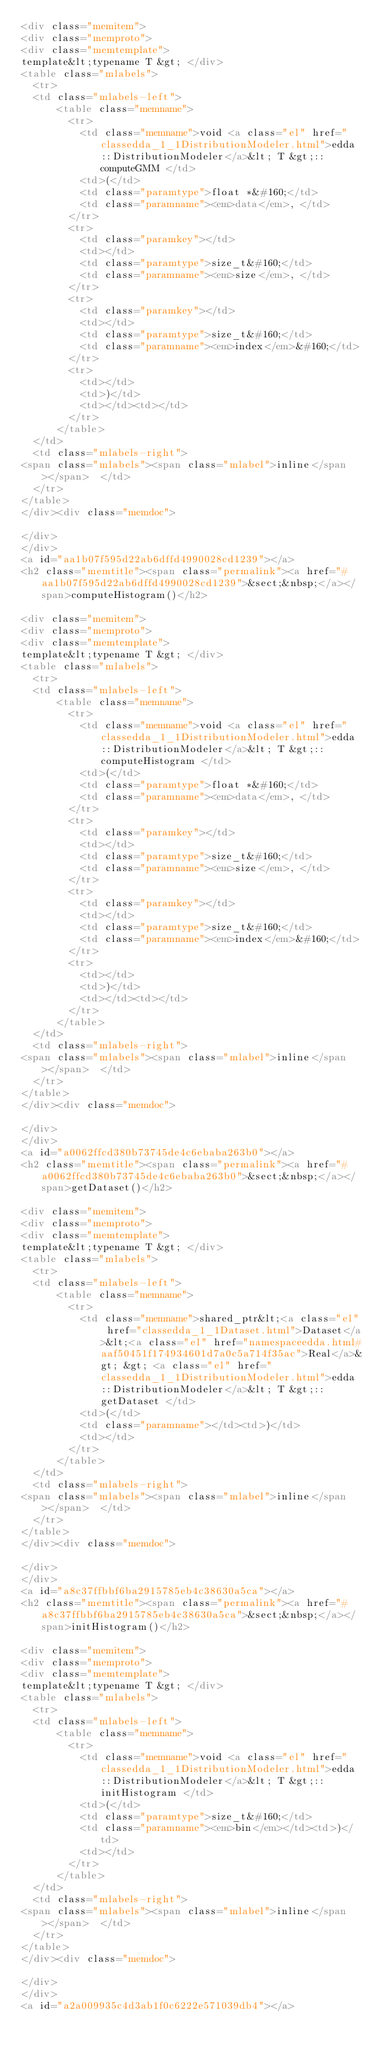<code> <loc_0><loc_0><loc_500><loc_500><_HTML_><div class="memitem">
<div class="memproto">
<div class="memtemplate">
template&lt;typename T &gt; </div>
<table class="mlabels">
  <tr>
  <td class="mlabels-left">
      <table class="memname">
        <tr>
          <td class="memname">void <a class="el" href="classedda_1_1DistributionModeler.html">edda::DistributionModeler</a>&lt; T &gt;::computeGMM </td>
          <td>(</td>
          <td class="paramtype">float *&#160;</td>
          <td class="paramname"><em>data</em>, </td>
        </tr>
        <tr>
          <td class="paramkey"></td>
          <td></td>
          <td class="paramtype">size_t&#160;</td>
          <td class="paramname"><em>size</em>, </td>
        </tr>
        <tr>
          <td class="paramkey"></td>
          <td></td>
          <td class="paramtype">size_t&#160;</td>
          <td class="paramname"><em>index</em>&#160;</td>
        </tr>
        <tr>
          <td></td>
          <td>)</td>
          <td></td><td></td>
        </tr>
      </table>
  </td>
  <td class="mlabels-right">
<span class="mlabels"><span class="mlabel">inline</span></span>  </td>
  </tr>
</table>
</div><div class="memdoc">

</div>
</div>
<a id="aa1b07f595d22ab6dffd4990028cd1239"></a>
<h2 class="memtitle"><span class="permalink"><a href="#aa1b07f595d22ab6dffd4990028cd1239">&sect;&nbsp;</a></span>computeHistogram()</h2>

<div class="memitem">
<div class="memproto">
<div class="memtemplate">
template&lt;typename T &gt; </div>
<table class="mlabels">
  <tr>
  <td class="mlabels-left">
      <table class="memname">
        <tr>
          <td class="memname">void <a class="el" href="classedda_1_1DistributionModeler.html">edda::DistributionModeler</a>&lt; T &gt;::computeHistogram </td>
          <td>(</td>
          <td class="paramtype">float *&#160;</td>
          <td class="paramname"><em>data</em>, </td>
        </tr>
        <tr>
          <td class="paramkey"></td>
          <td></td>
          <td class="paramtype">size_t&#160;</td>
          <td class="paramname"><em>size</em>, </td>
        </tr>
        <tr>
          <td class="paramkey"></td>
          <td></td>
          <td class="paramtype">size_t&#160;</td>
          <td class="paramname"><em>index</em>&#160;</td>
        </tr>
        <tr>
          <td></td>
          <td>)</td>
          <td></td><td></td>
        </tr>
      </table>
  </td>
  <td class="mlabels-right">
<span class="mlabels"><span class="mlabel">inline</span></span>  </td>
  </tr>
</table>
</div><div class="memdoc">

</div>
</div>
<a id="a0062ffcd380b73745de4c6ebaba263b0"></a>
<h2 class="memtitle"><span class="permalink"><a href="#a0062ffcd380b73745de4c6ebaba263b0">&sect;&nbsp;</a></span>getDataset()</h2>

<div class="memitem">
<div class="memproto">
<div class="memtemplate">
template&lt;typename T &gt; </div>
<table class="mlabels">
  <tr>
  <td class="mlabels-left">
      <table class="memname">
        <tr>
          <td class="memname">shared_ptr&lt;<a class="el" href="classedda_1_1Dataset.html">Dataset</a>&lt;<a class="el" href="namespaceedda.html#aaf50451f174934601d7a0c5a714f35ac">Real</a>&gt; &gt; <a class="el" href="classedda_1_1DistributionModeler.html">edda::DistributionModeler</a>&lt; T &gt;::getDataset </td>
          <td>(</td>
          <td class="paramname"></td><td>)</td>
          <td></td>
        </tr>
      </table>
  </td>
  <td class="mlabels-right">
<span class="mlabels"><span class="mlabel">inline</span></span>  </td>
  </tr>
</table>
</div><div class="memdoc">

</div>
</div>
<a id="a8c37ffbbf6ba2915785eb4c38630a5ca"></a>
<h2 class="memtitle"><span class="permalink"><a href="#a8c37ffbbf6ba2915785eb4c38630a5ca">&sect;&nbsp;</a></span>initHistogram()</h2>

<div class="memitem">
<div class="memproto">
<div class="memtemplate">
template&lt;typename T &gt; </div>
<table class="mlabels">
  <tr>
  <td class="mlabels-left">
      <table class="memname">
        <tr>
          <td class="memname">void <a class="el" href="classedda_1_1DistributionModeler.html">edda::DistributionModeler</a>&lt; T &gt;::initHistogram </td>
          <td>(</td>
          <td class="paramtype">size_t&#160;</td>
          <td class="paramname"><em>bin</em></td><td>)</td>
          <td></td>
        </tr>
      </table>
  </td>
  <td class="mlabels-right">
<span class="mlabels"><span class="mlabel">inline</span></span>  </td>
  </tr>
</table>
</div><div class="memdoc">

</div>
</div>
<a id="a2a009935c4d3ab1f0c6222e571039db4"></a></code> 